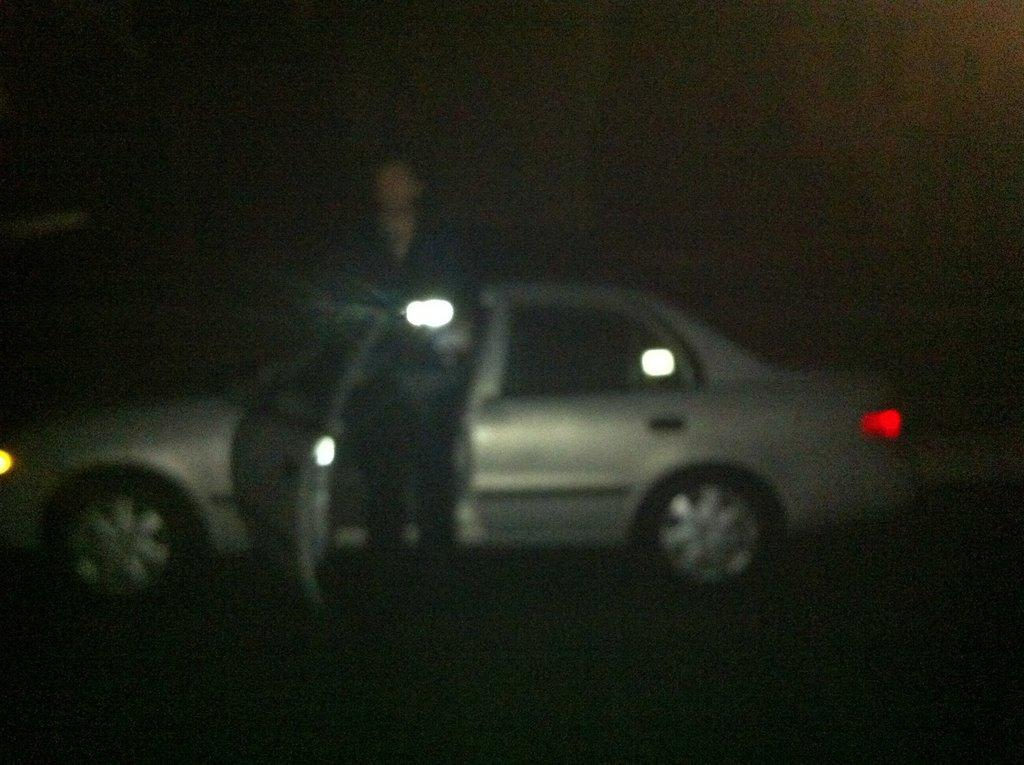What type of object is the main subject in the image? There is a motor vehicle in the image. Where is the motor vehicle located? The motor vehicle is on the road. Are there any people present in the image? Yes, there is a person standing in the image. What type of fowl can be seen playing on the playground in the image? There is no playground or fowl present in the image. 